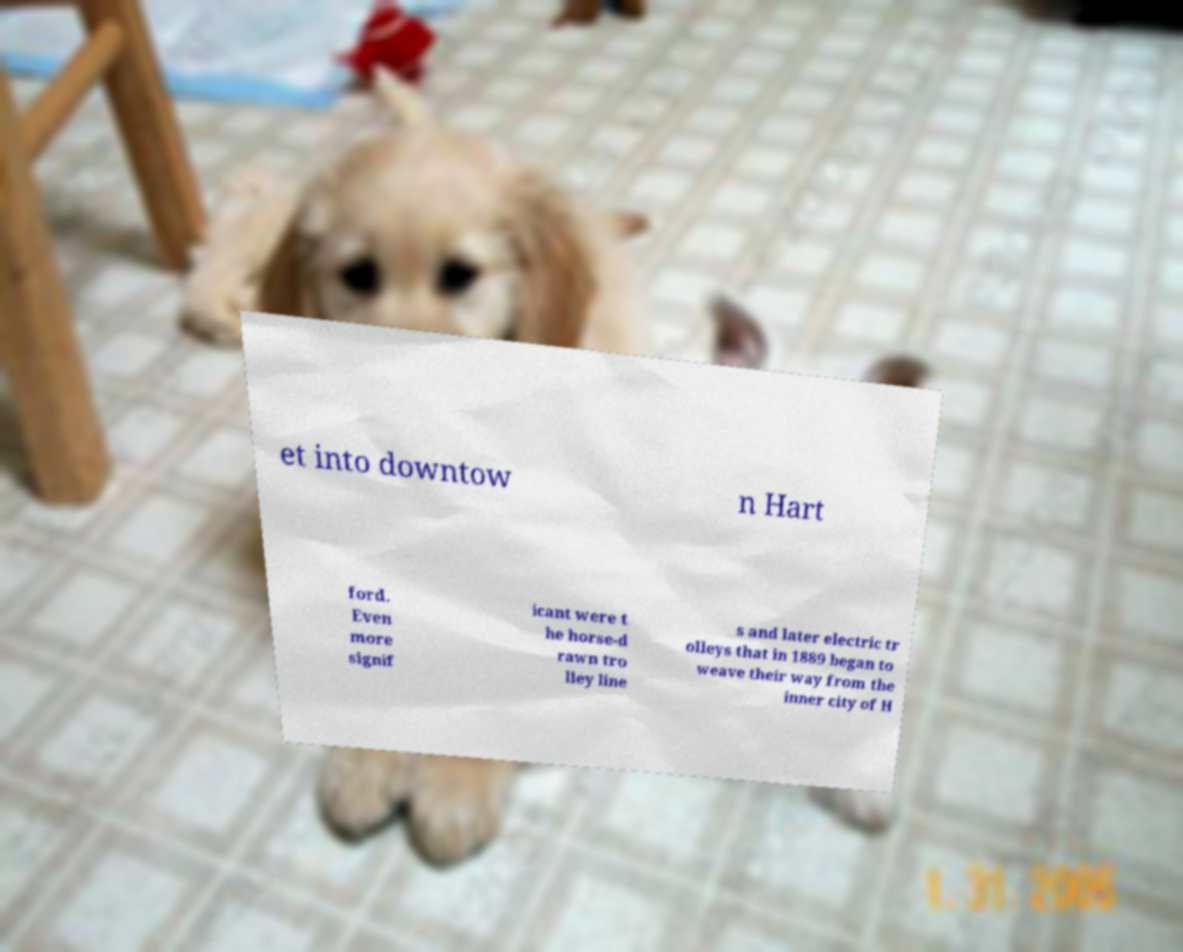Please identify and transcribe the text found in this image. et into downtow n Hart ford. Even more signif icant were t he horse-d rawn tro lley line s and later electric tr olleys that in 1889 began to weave their way from the inner city of H 